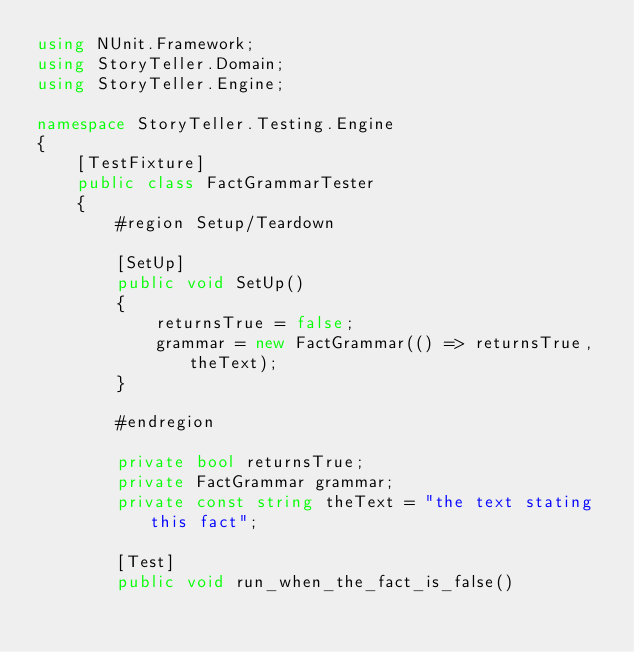Convert code to text. <code><loc_0><loc_0><loc_500><loc_500><_C#_>using NUnit.Framework;
using StoryTeller.Domain;
using StoryTeller.Engine;

namespace StoryTeller.Testing.Engine
{
    [TestFixture]
    public class FactGrammarTester
    {
        #region Setup/Teardown

        [SetUp]
        public void SetUp()
        {
            returnsTrue = false;
            grammar = new FactGrammar(() => returnsTrue, theText);
        }

        #endregion

        private bool returnsTrue;
        private FactGrammar grammar;
        private const string theText = "the text stating this fact";

        [Test]
        public void run_when_the_fact_is_false()</code> 